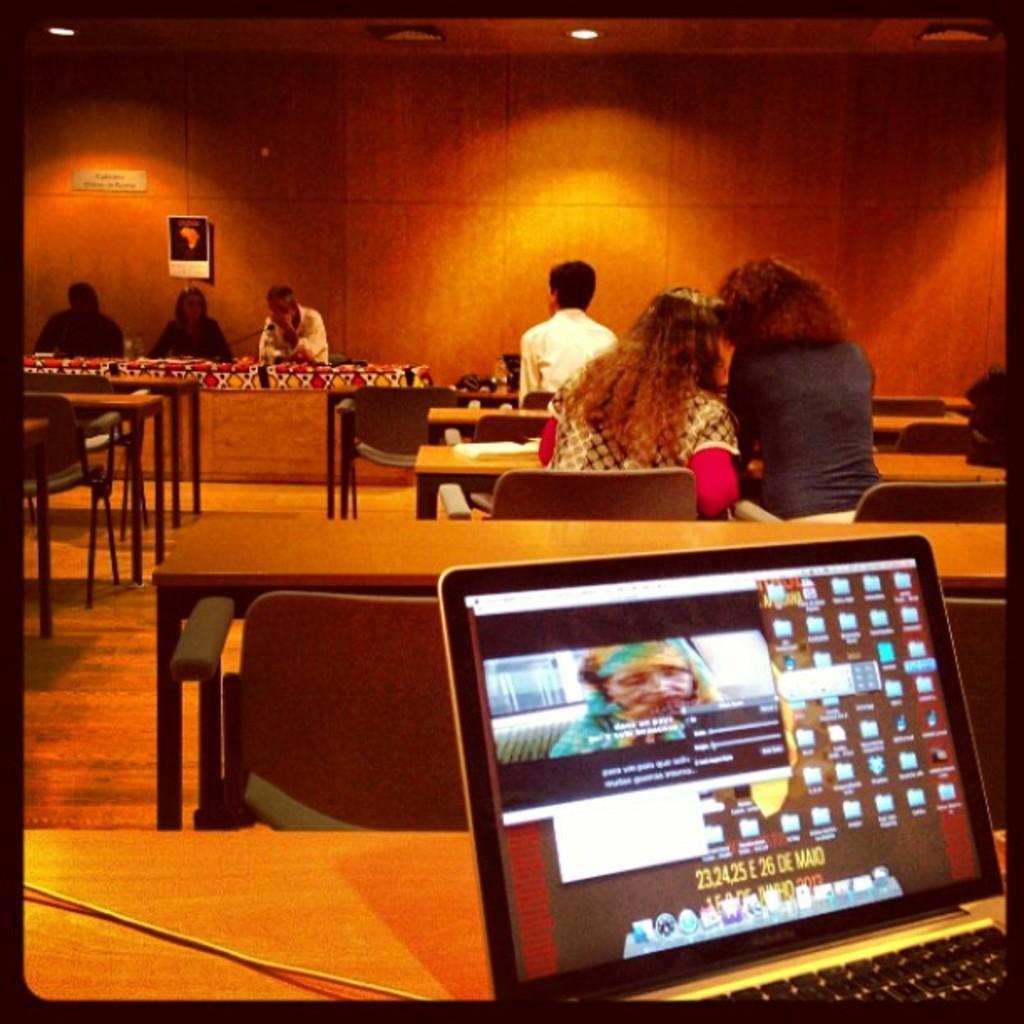How would you summarize this image in a sentence or two? This is the laptop placed on the table. These are the chairs on the floor. There are two women sitting on the chairs very closely. This is the wooden wall. This man is sitting in front of the two women. These three people are sitting in front of the table and speaking. This is the ceiling of the room. 